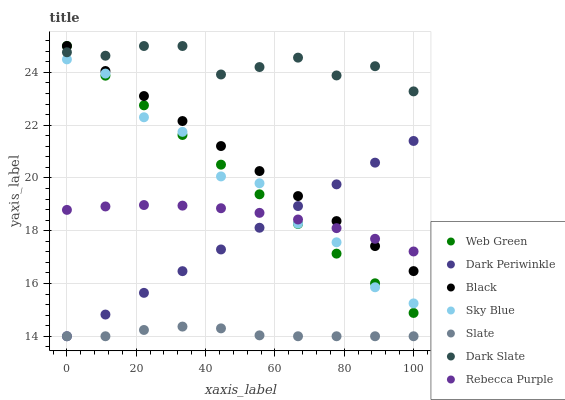Does Slate have the minimum area under the curve?
Answer yes or no. Yes. Does Dark Slate have the maximum area under the curve?
Answer yes or no. Yes. Does Web Green have the minimum area under the curve?
Answer yes or no. No. Does Web Green have the maximum area under the curve?
Answer yes or no. No. Is Web Green the smoothest?
Answer yes or no. Yes. Is Sky Blue the roughest?
Answer yes or no. Yes. Is Dark Slate the smoothest?
Answer yes or no. No. Is Dark Slate the roughest?
Answer yes or no. No. Does Slate have the lowest value?
Answer yes or no. Yes. Does Web Green have the lowest value?
Answer yes or no. No. Does Black have the highest value?
Answer yes or no. Yes. Does Rebecca Purple have the highest value?
Answer yes or no. No. Is Dark Periwinkle less than Dark Slate?
Answer yes or no. Yes. Is Dark Slate greater than Slate?
Answer yes or no. Yes. Does Web Green intersect Sky Blue?
Answer yes or no. Yes. Is Web Green less than Sky Blue?
Answer yes or no. No. Is Web Green greater than Sky Blue?
Answer yes or no. No. Does Dark Periwinkle intersect Dark Slate?
Answer yes or no. No. 